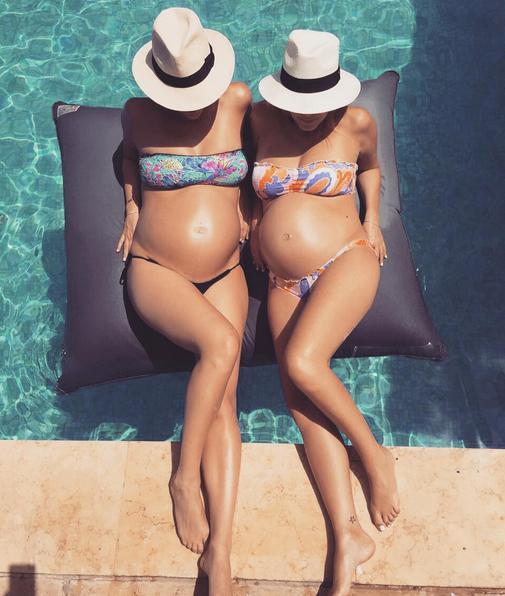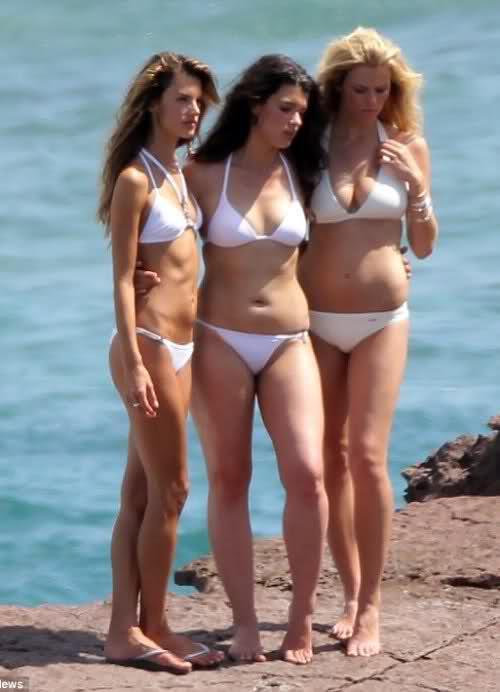The first image is the image on the left, the second image is the image on the right. Considering the images on both sides, is "Right image shows three bikini-wearing women standing close together." valid? Answer yes or no. Yes. The first image is the image on the left, the second image is the image on the right. For the images displayed, is the sentence "There is at least one pregnant woman." factually correct? Answer yes or no. Yes. 